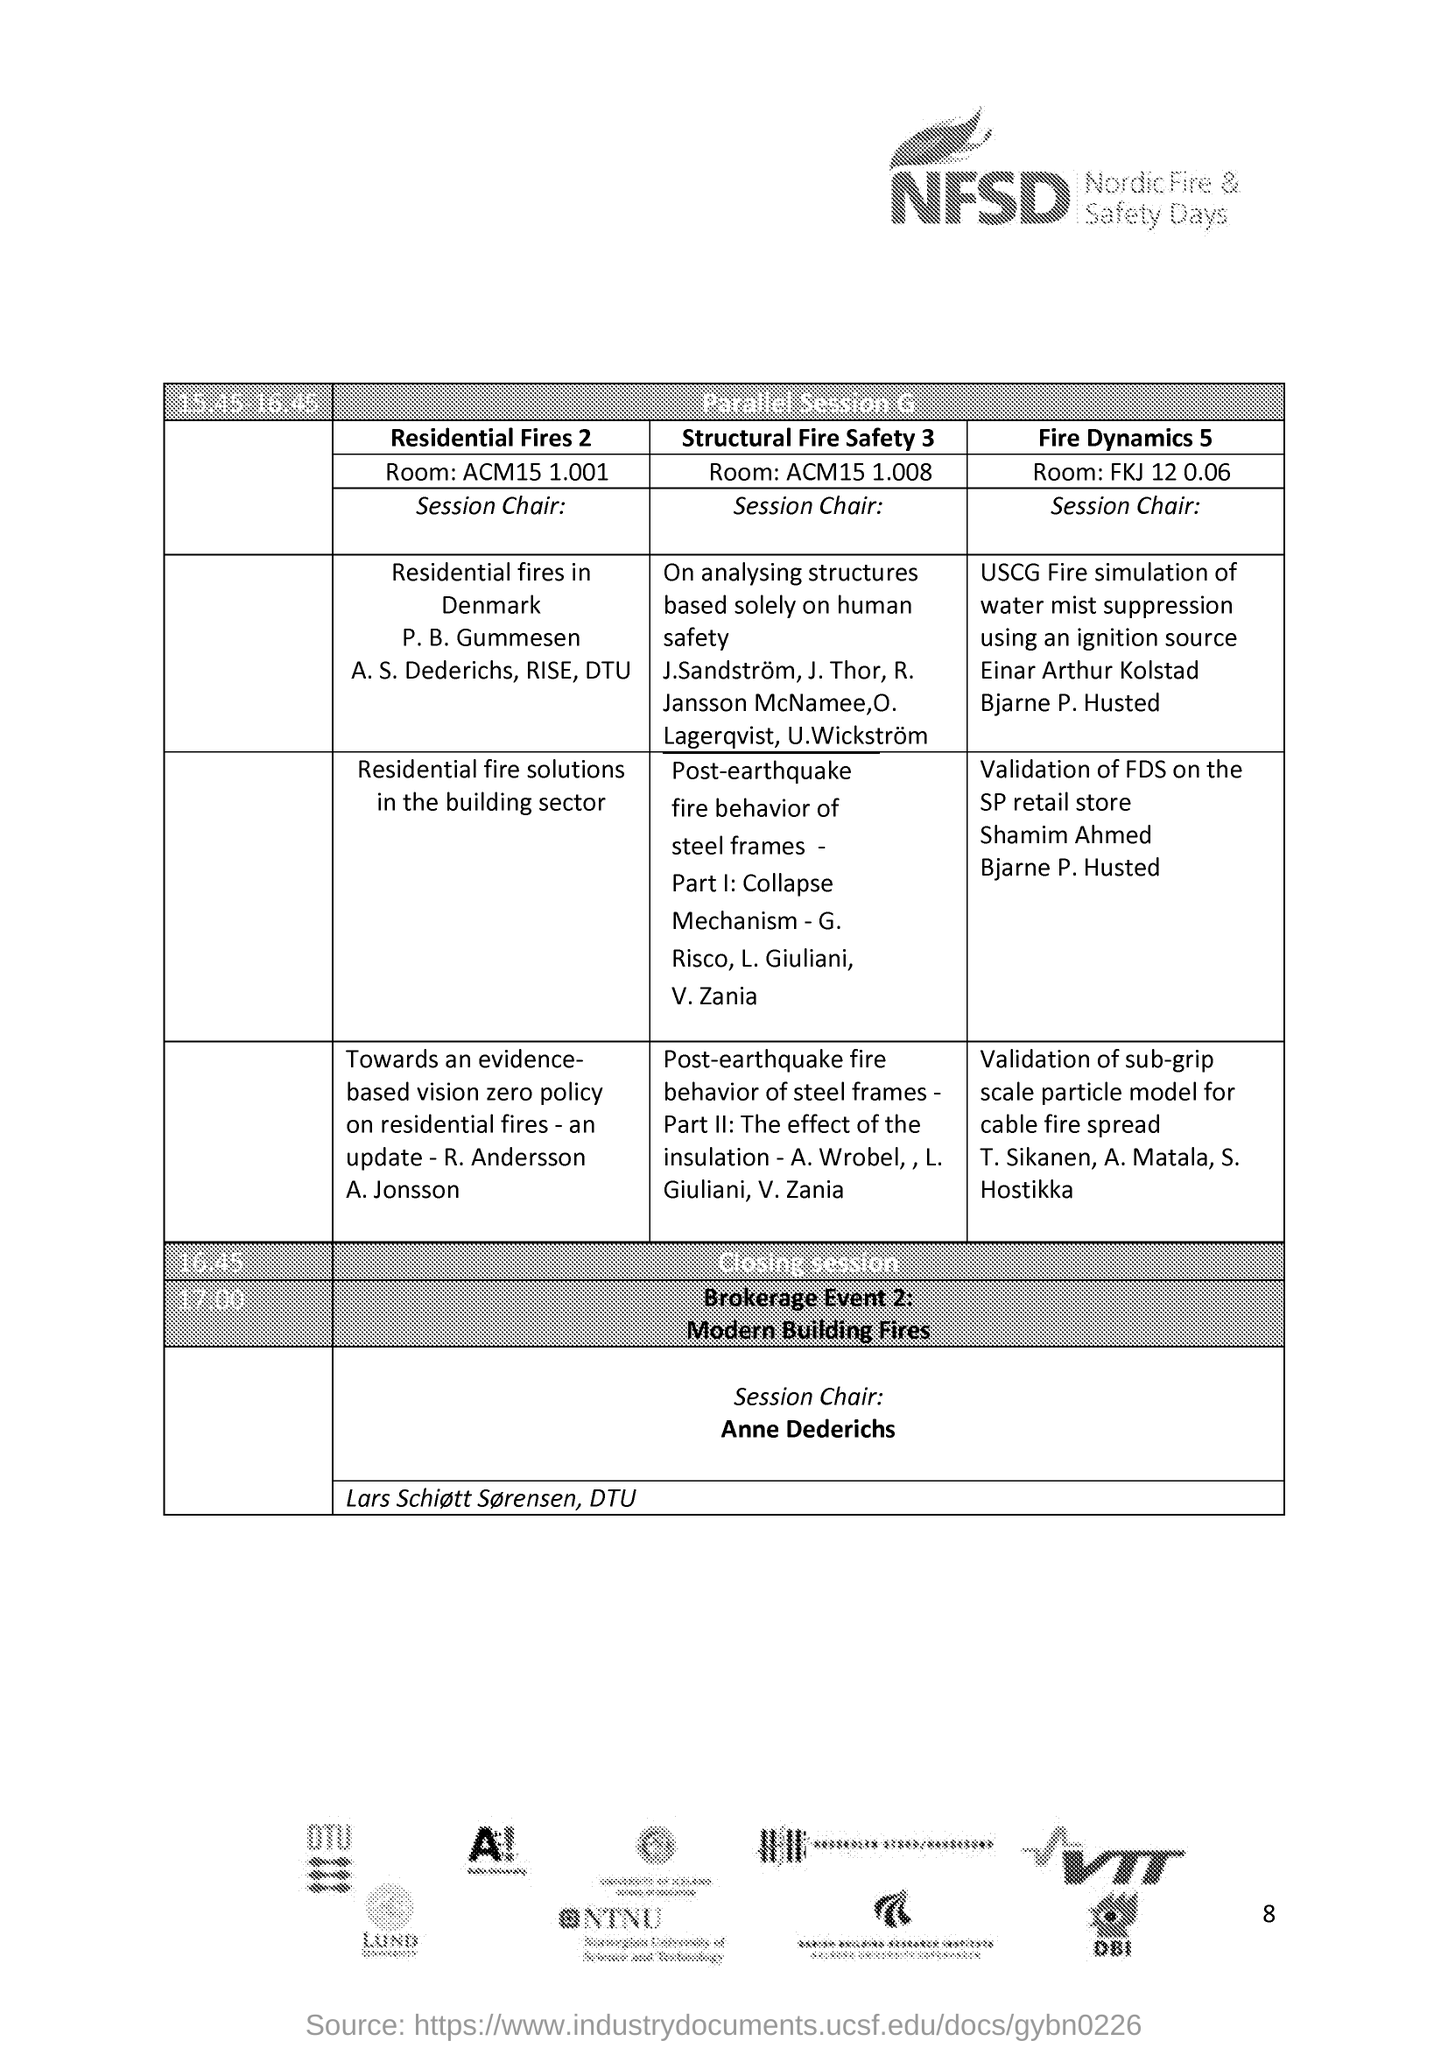Highlight a few significant elements in this photo. The session is scheduled to end at 4:45 PM. NFSD stands for Nordic Fire & Safety Days, which is a event that focuses on fire and safety related matters in the Nordic region. 